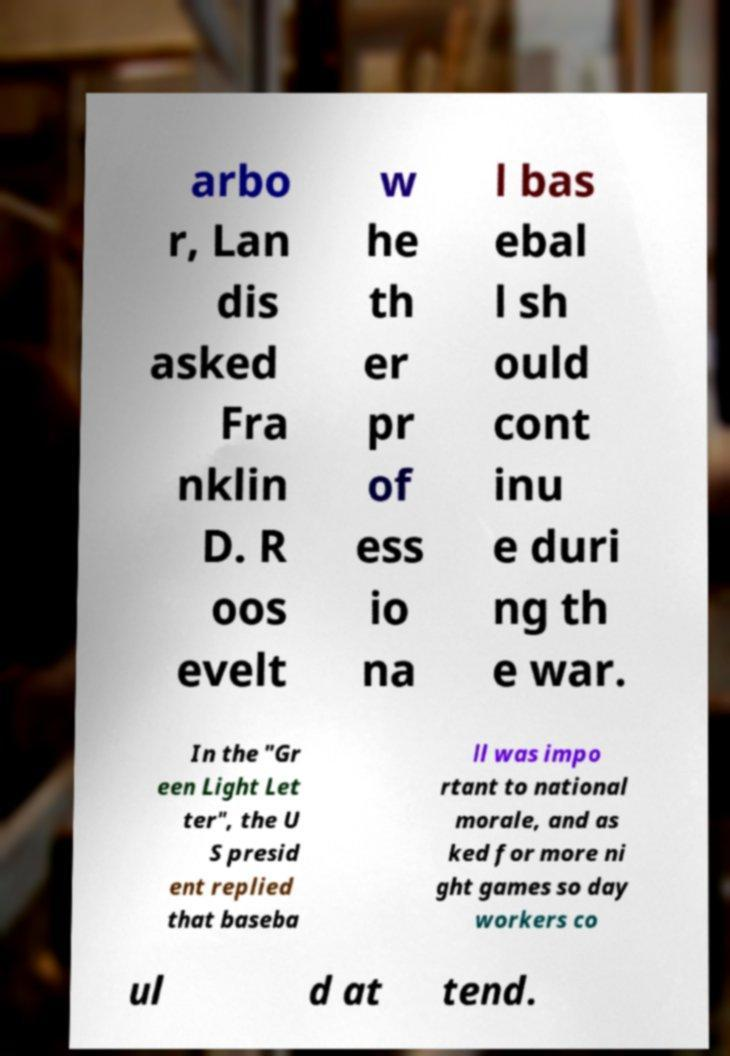Please identify and transcribe the text found in this image. arbo r, Lan dis asked Fra nklin D. R oos evelt w he th er pr of ess io na l bas ebal l sh ould cont inu e duri ng th e war. In the "Gr een Light Let ter", the U S presid ent replied that baseba ll was impo rtant to national morale, and as ked for more ni ght games so day workers co ul d at tend. 